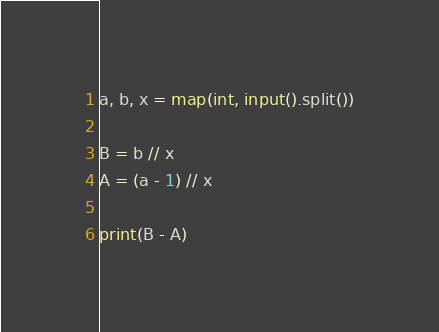Convert code to text. <code><loc_0><loc_0><loc_500><loc_500><_Python_>a, b, x = map(int, input().split())

B = b // x
A = (a - 1) // x

print(B - A)</code> 